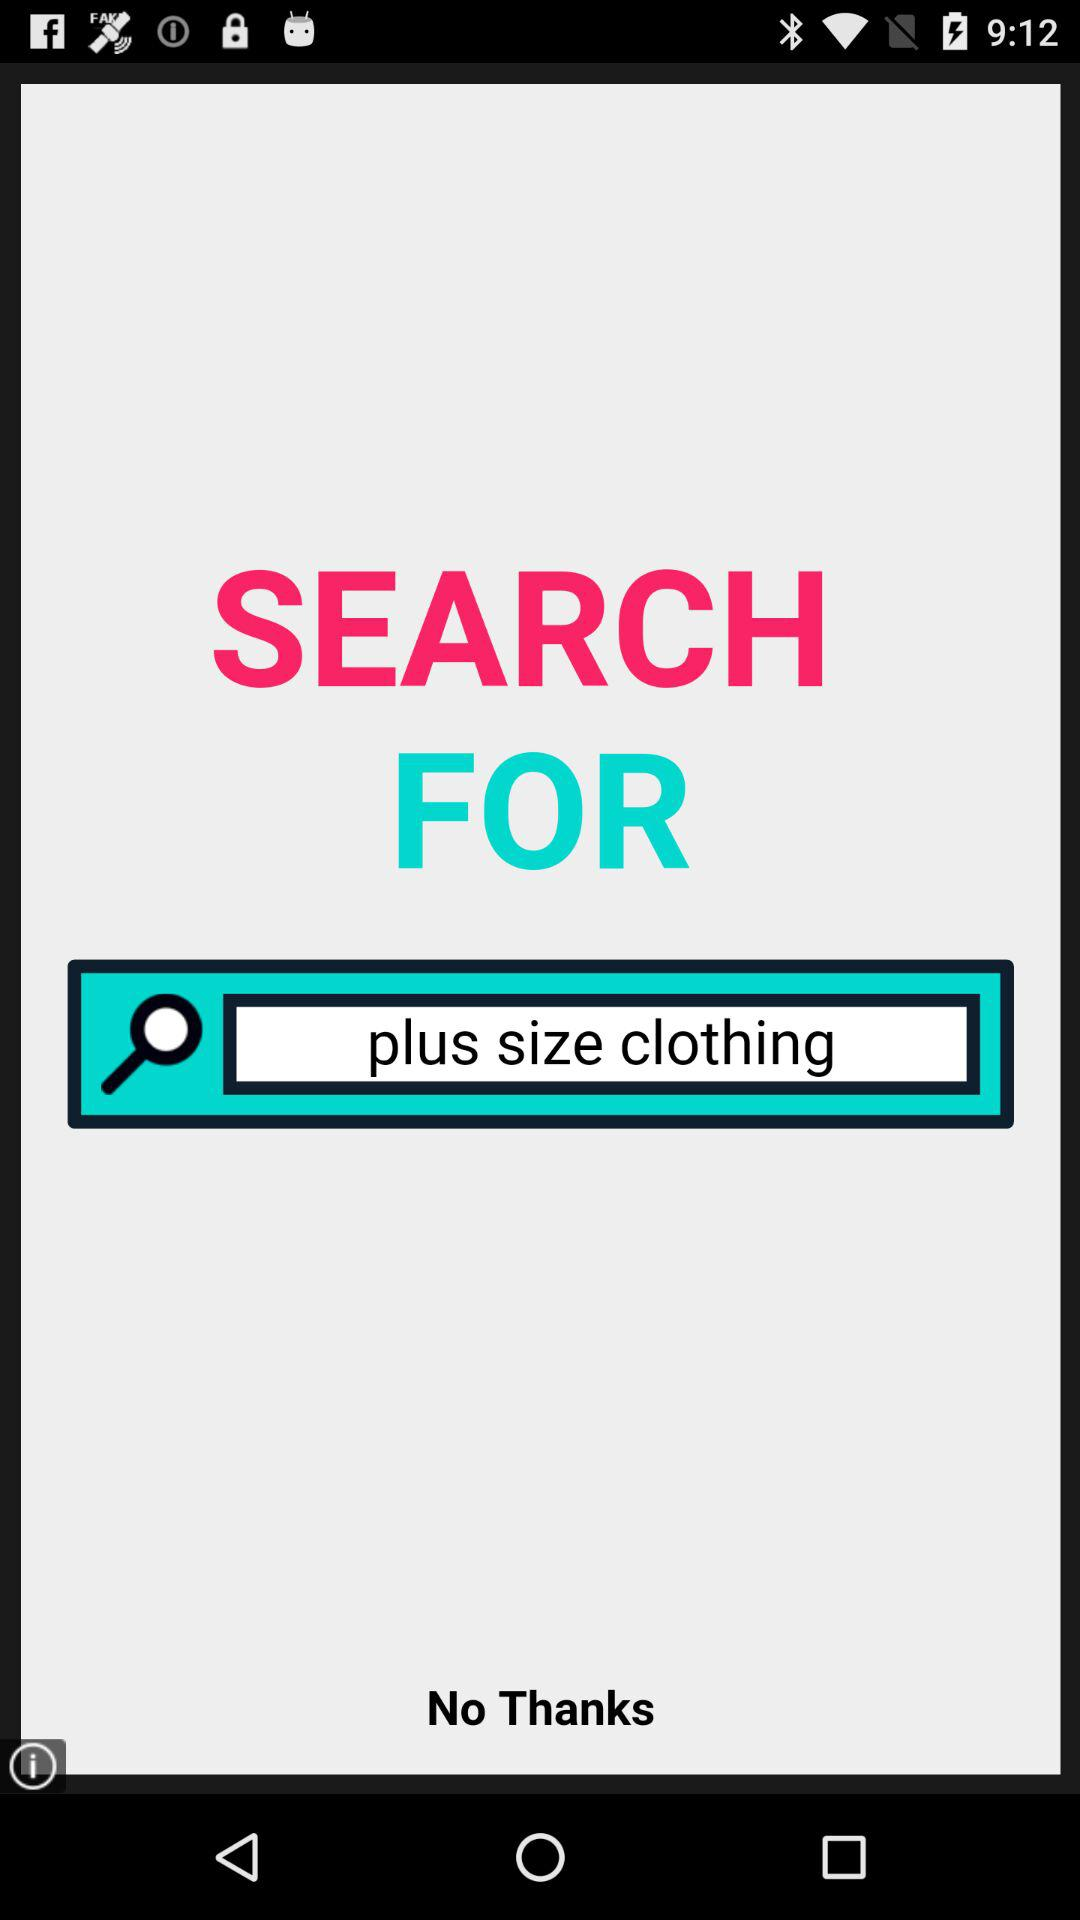What is the text entered in the search bar? The text is "plus size clothing". 